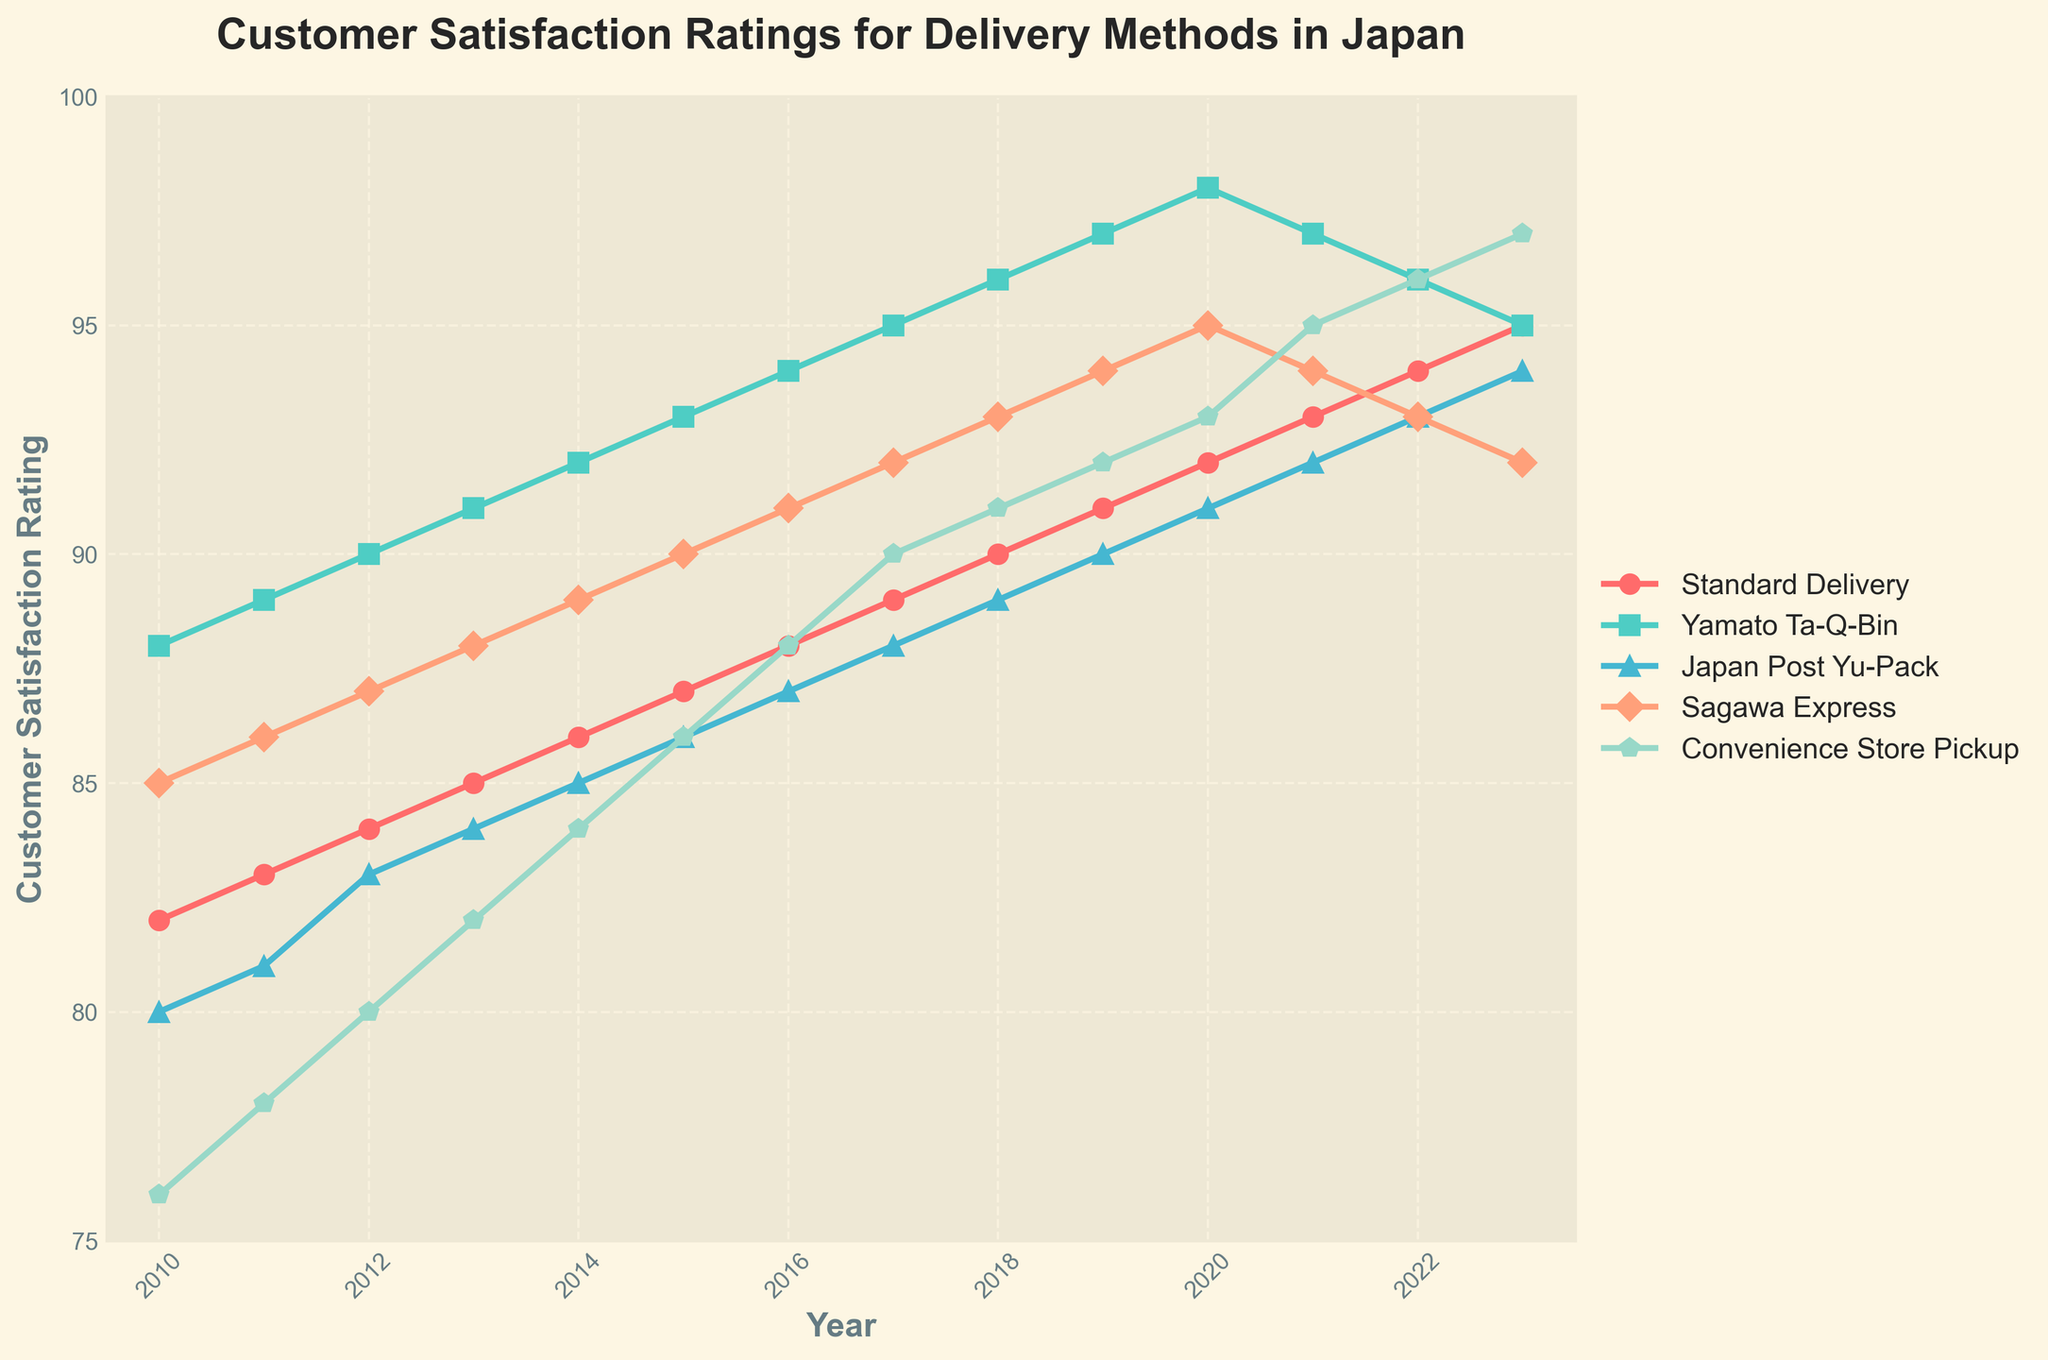What years are displayed on the x-axis? The x-axis represents the years. By inspecting its labels, we can see it's ranging from 2010 to 2023.
Answer: 2010 to 2023 Which delivery method had the highest customer satisfaction in 2021? In 2021, the line representing Convenience Store Pickup reaches the highest point in that year compared to other delivery methods, with a rating of 95.
Answer: Convenience Store Pickup Which delivery method showed the most consistent increase in customer satisfaction from 2010 to 2023? By examining the lines, Yamato Ta-Q-Bin shows a steady upward trend from 88 in 2010 to 95 in 2023, indicating the most consistent increase.
Answer: Yamato Ta-Q-Bin Between 2015 and 2018, which delivery method saw the greatest increase in customer satisfaction? By calculating the difference in satisfaction levels between 2015 and 2018 for each method, Convenience Store Pickup has the largest increase from 86 to 91, an increase of 5.
Answer: Convenience Store Pickup How many times did Sagawa Express's customer satisfaction drop from one year to the next between 2010 and 2023? By tracing the line for Sagawa Express and noting when it decreases, it shows drops from 2021 to 2022 and from 2022 to 2023 – totaling 2 drops.
Answer: 2 times What is the average customer satisfaction for Standard Delivery from 2010 to 2023? Summing all points for Standard Delivery and then dividing by the total number of years: (82+83+84+85+86+87+88+89+90+91+92+93+94+95) / 14 = 88.71.
Answer: 88.71 Which delivery method had the highest customer satisfaction in 2010 and which had the lowest? In 2010, Yamato Ta-Q-Bin had the highest rating at 88, and Convenience Store Pickup had the lowest at 76.
Answer: Yamato Ta-Q-Bin had the highest, Convenience Store Pickup had the lowest Did any delivery method’s customer satisfaction ratings ever reach 100 from 2010 to 2023? No line reaches 100 within the displayed years, indicating no method achieved a 100 rating.
Answer: No Which year saw Yamato Ta-Q-Bin customer satisfaction reach its peak and what was the rating? By following Yamato Ta-Q-Bin's line, its peak is reached in 2020 with a rating of 98.
Answer: 2020, 98 Which delivery method had the largest decline in customer satisfaction between 2022 and 2023? Observing the slope between 2022 and 2023, Japan Post Yu-Pack shows the largest decline from 93 to 92, a decrease of 1 point.
Answer: Japan Post Yu-Pack 